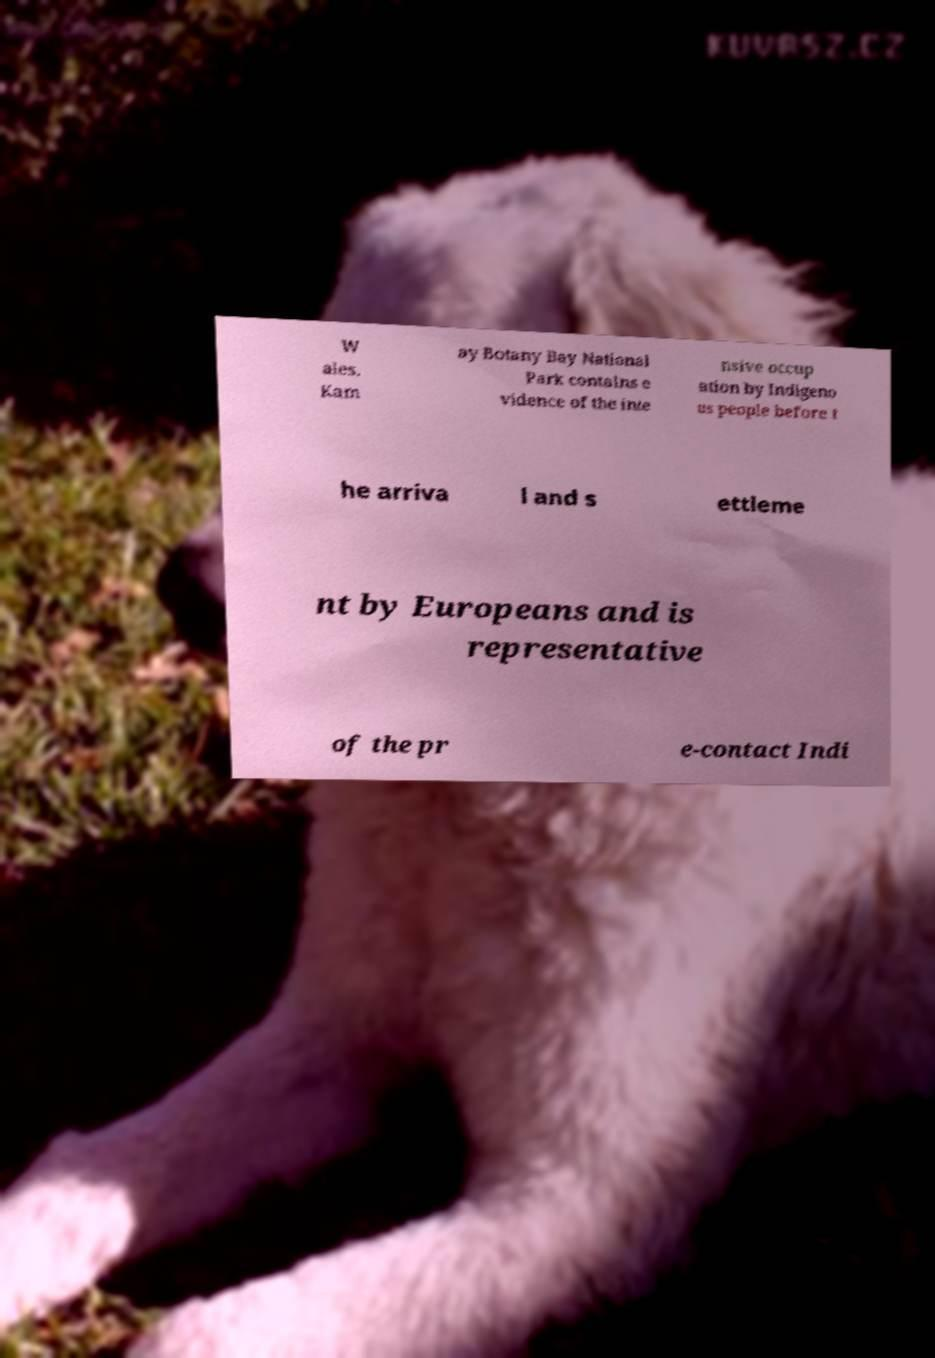Can you read and provide the text displayed in the image?This photo seems to have some interesting text. Can you extract and type it out for me? W ales. Kam ay Botany Bay National Park contains e vidence of the inte nsive occup ation by Indigeno us people before t he arriva l and s ettleme nt by Europeans and is representative of the pr e-contact Indi 